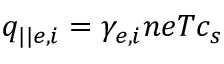Convert formula to latex. <formula><loc_0><loc_0><loc_500><loc_500>q _ { | | e , i } = \gamma _ { e , i } n e T c _ { s }</formula> 